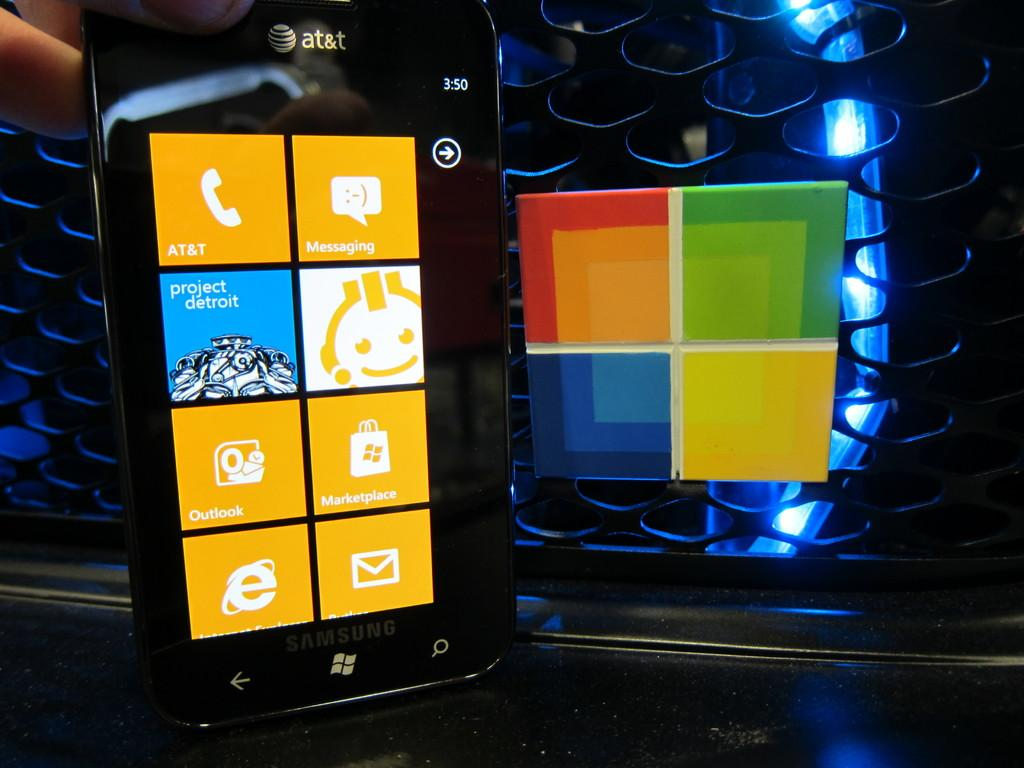<image>
Relay a brief, clear account of the picture shown. The screen of a windows phone with the logo for at&t on the top. 